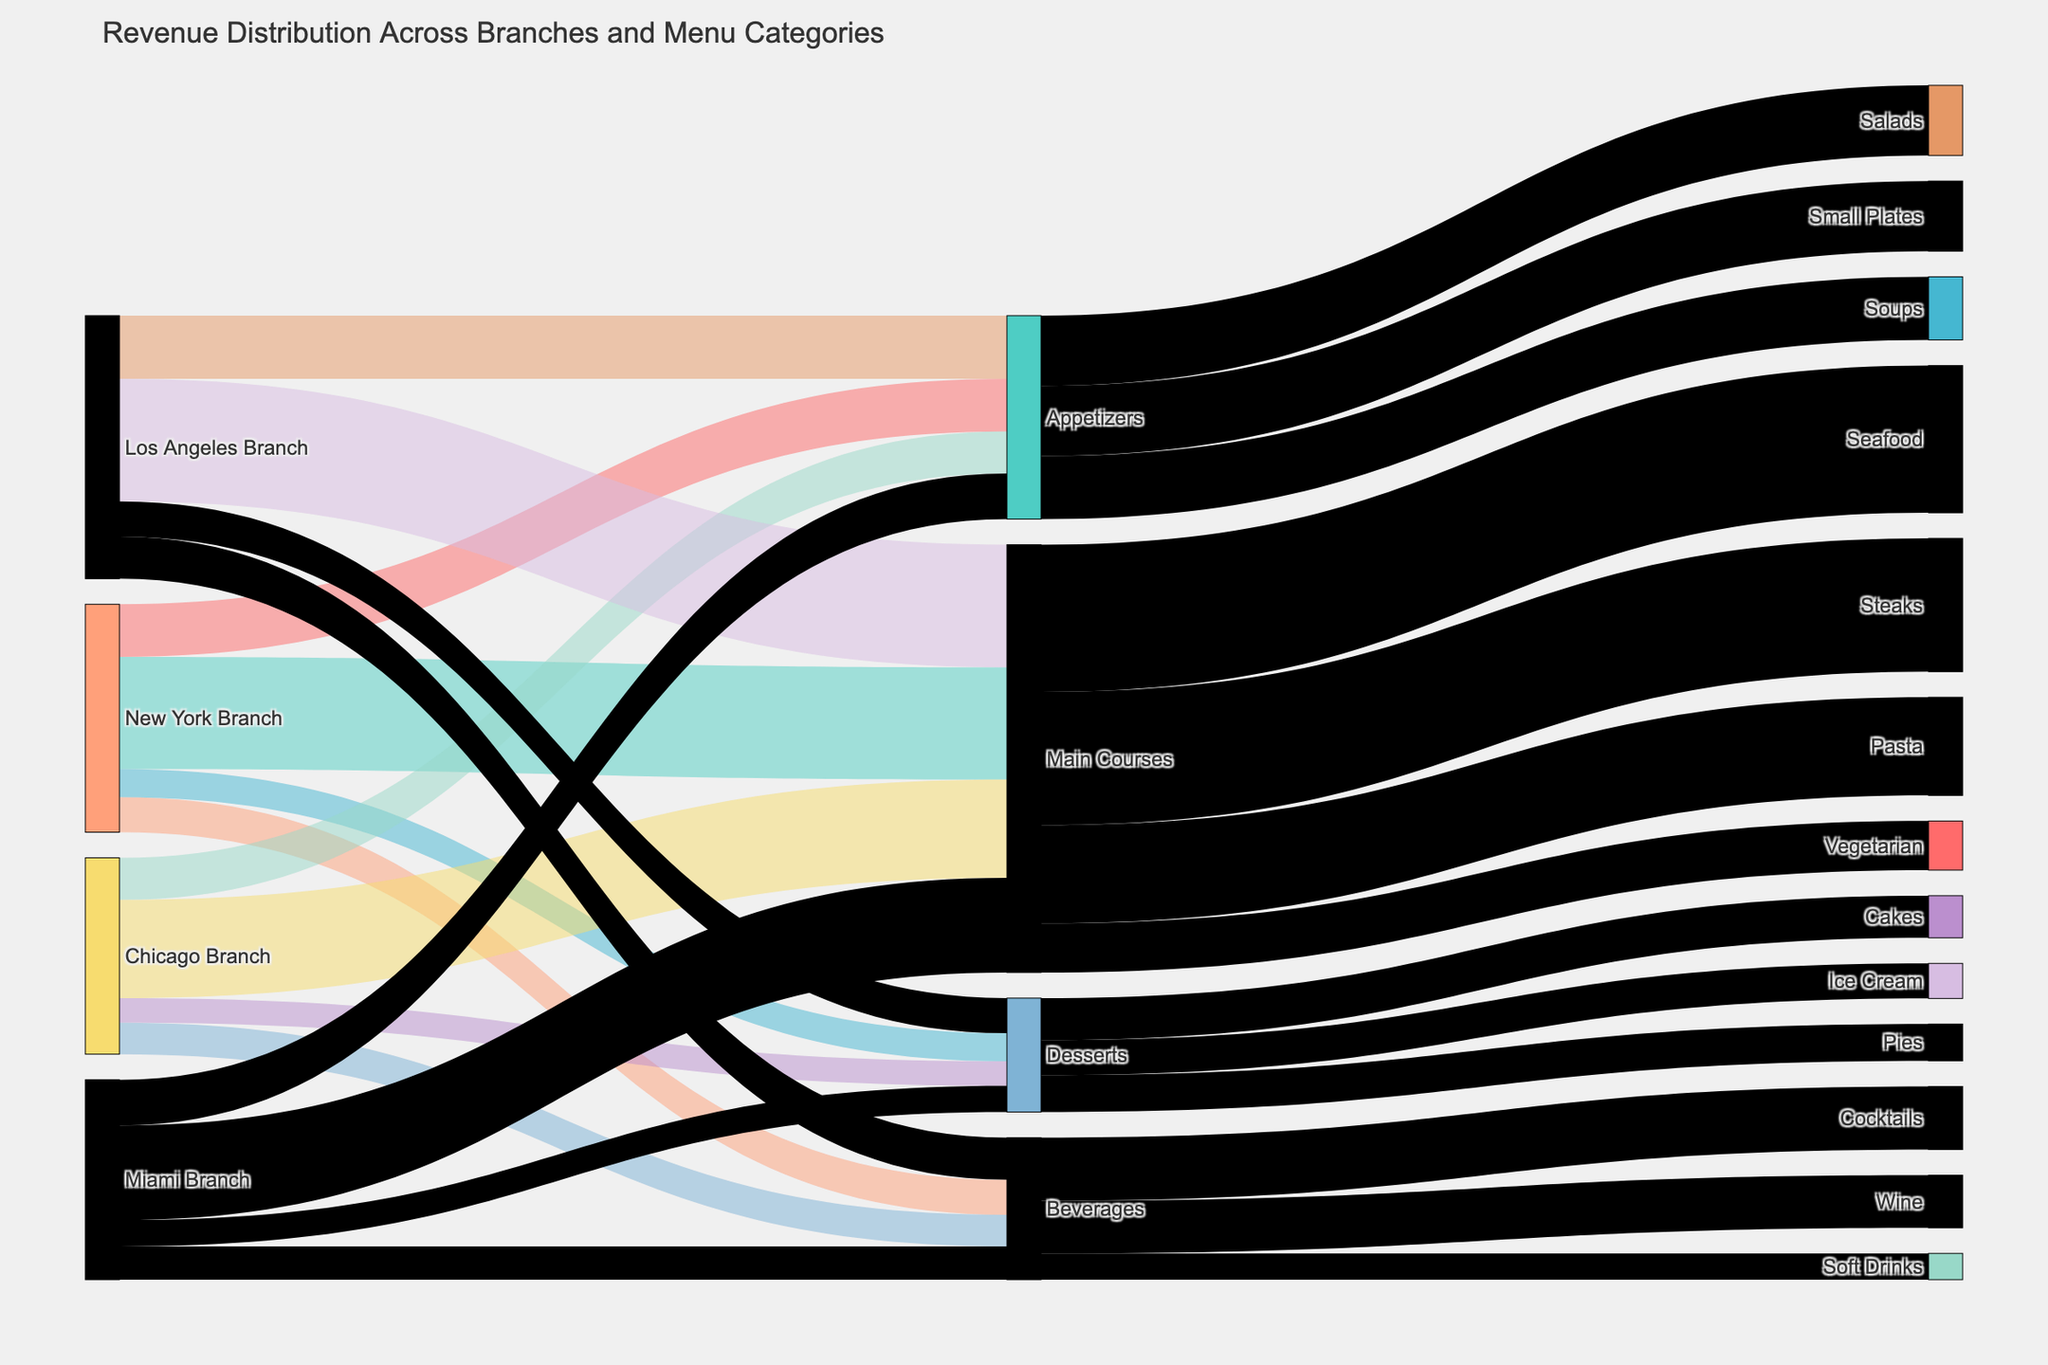What's the total revenue for the New York Branch? Sum up the revenues for each category in the New York Branch: 150,000 (Appetizers) + 320,000 (Main Courses) + 80,000 (Desserts) + 100,000 (Beverages) = 650,000
Answer: 650,000 Which branch has the highest revenue from Main Courses? Compare the revenue from Main Courses for each branch: New York (320,000), Chicago (280,000), Los Angeles (350,000), and Miami (270,000). The highest is Los Angeles with 350,000.
Answer: Los Angeles How much revenue comes from Desserts in total for all branches? Sum up the revenue from Desserts for all branches: 80,000 (New York) + 70,000 (Chicago) + 100,000 (Los Angeles) + 75,000 (Miami) = 325,000
Answer: 325,000 Which category within Main Courses generates the most revenue? Compare the revenues within Main Courses: Seafood (420,000), Steaks (380,000), Pasta (280,000), Vegetarian (140,000). Seafood generates the most with 420,000.
Answer: Seafood What's the difference in revenue from Beverages between New York and Miami branches? Subtract the revenue from Beverages in Miami from New York: 100,000 (New York) - 95,000 (Miami) = 5,000
Answer: 5,000 Which category has the highest revenue within Beverages? Compare the revenues within Beverages: Cocktails (180,000), Wine (150,000), Soft Drinks (75,000). Cocktails have the highest with 180,000.
Answer: Cocktails How does the revenue from Appetizers in Los Angeles compare to that in Chicago? Compare the revenue from Appetizers: Los Angeles (180,000) vs. Chicago (120,000). Los Angeles has 60,000 more than Chicago (180,000 - 120,000).
Answer: 60,000 more What percentage of the total revenue of New York Branch is from Main Courses? Calculate the total revenue of New York Branch: 650,000. Then, find the percentage contribution of Main Courses: (320,000 / 650,000) * 100 ≈ 49.23%
Answer: 49.23% What's the sum of revenue generated from Cakes and Pies within Desserts? Add up the revenue from Cakes and Pies: 120,000 (Cakes) + 105,000 (Pies) = 225,000
Answer: 225,000 